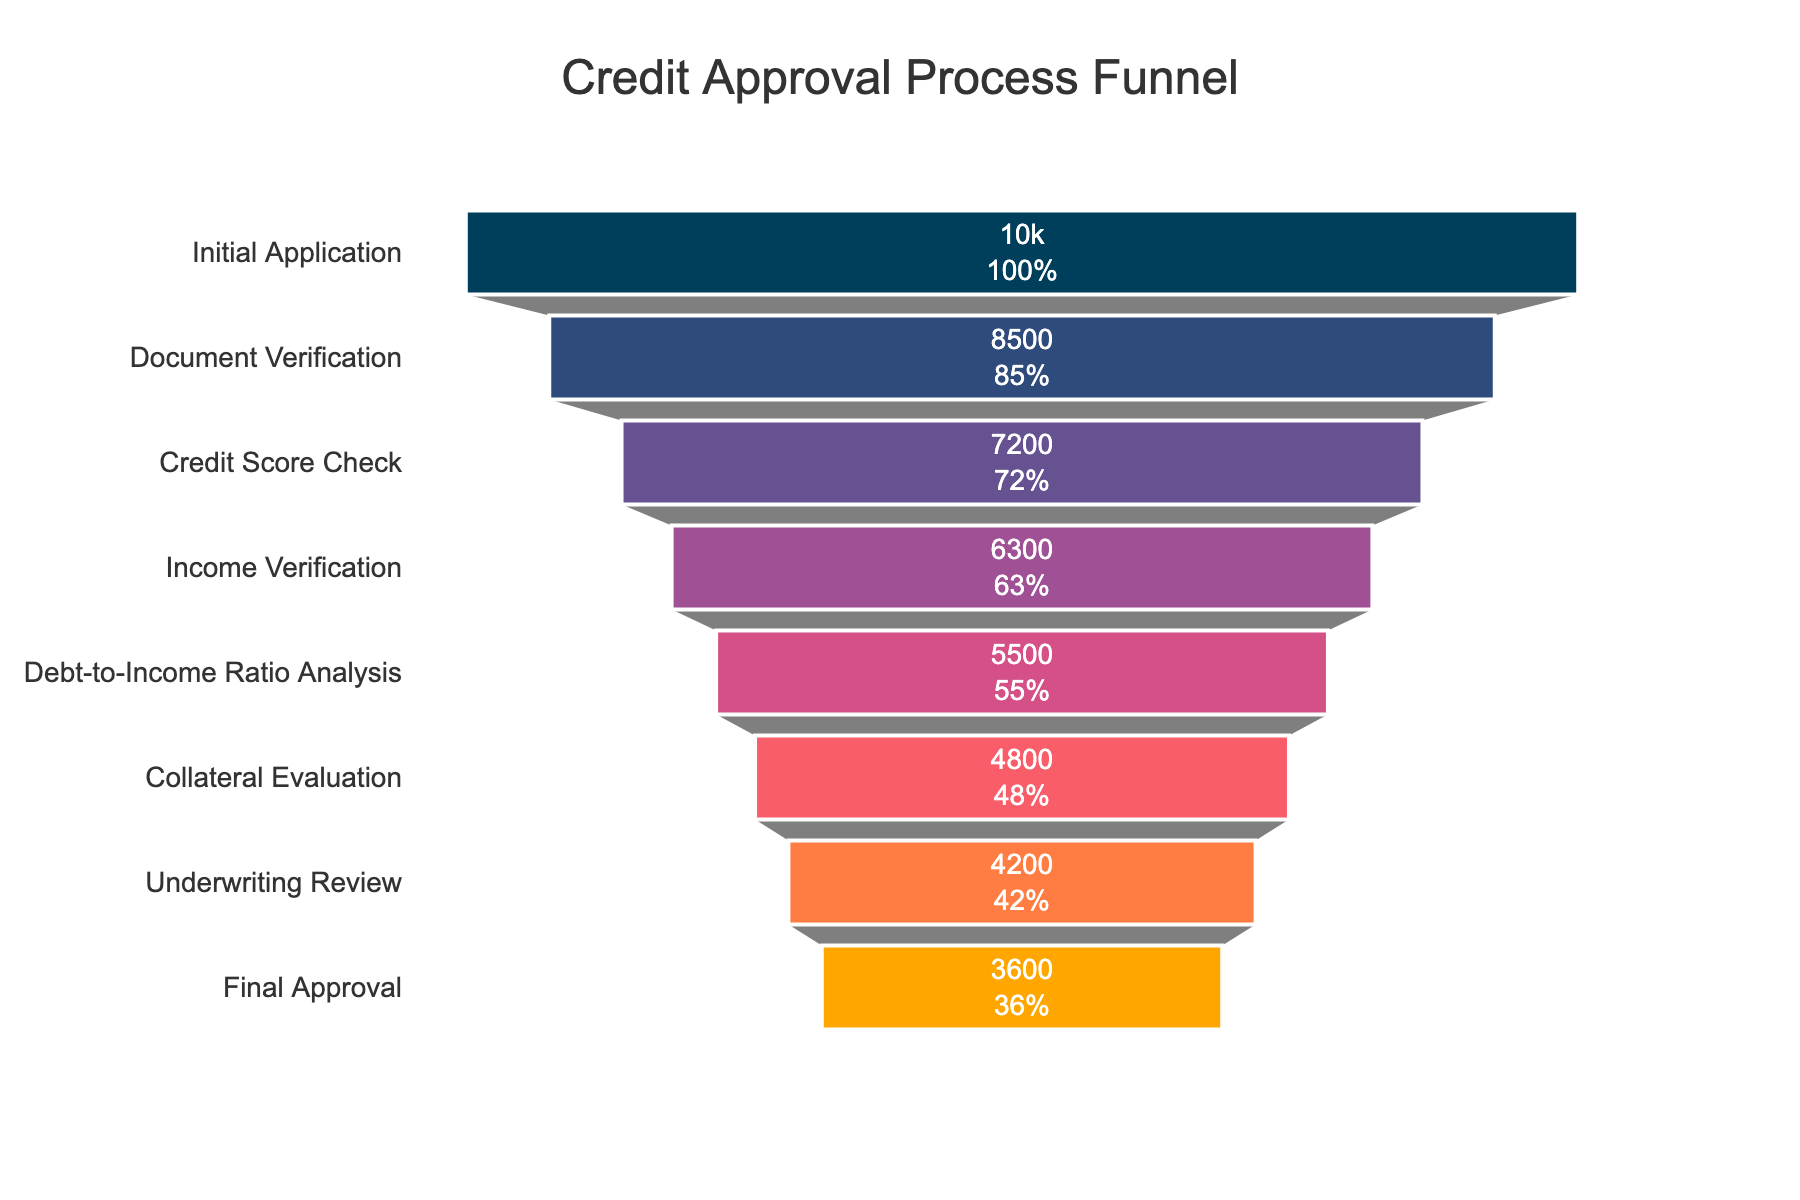What stage has the highest number of applicants? The top of the funnel chart has the greatest width, indicating the stage with the highest number of applicants. This stage is labeled "Initial Application".
Answer: Initial Application What stage sees the biggest drop in applicant numbers? Compare the drop between each sequential stage, i.e., the difference between applicants in each subsequent stage. The biggest drop is between "Initial Application" (10000 applicants) and "Document Verification" (8500 applicants). The difference is 1500 applicants.
Answer: Initial Application to Document Verification How many applicants remain after the Credit Score Check stage? The funnel section corresponding to "Credit Score Check" shows 7200 applicants.
Answer: 7200 What is the percentage of applicants who reach the Final Approval stage relative to the Initial Application stage? To find the percentage, divide the number of applicants at the Final Approval stage (3600) by the number at the Initial Application stage (10000) and multiply by 100: (3600 / 10000) * 100.
Answer: 36% Which stage has around a 20% drop from the previous stage? Calculate the percentage drop for each stage by comparing the current stage's applicants to the prior stage's applicants. The stage where the drop is close to 20% is "Collateral Evaluation" from "Debt-to-Income Ratio Analysis" (5500 - 4800 = 700; 700 / 5500 * 100 = approximately 12.73%) and "Underwriting Review" from "Collateral Evaluation" (4800 - 4200 = 600; 600 / 4800 * 100 = approximately 12.5%).
Answer: No exact match Which stage has the lowest number of applicants? The bottom of the funnel is the narrowest, indicating the lowest number of applicants. This stage is labeled "Final Approval".
Answer: Final Approval What is the total number of applicants lost from the Initial Application stage to the Final Approval stage? Subtract the number of applicants at the Final Approval stage (3600) from those at the Initial Application stage (10000): 10000 - 3600.
Answer: 6400 How many stages have more than 7000 applicants? Count the number of stages where applicant numbers are greater than 7000. These stages are "Initial Application" (10000), "Document Verification" (8500), and "Credit Score Check" (7200).
Answer: 3 Is the drop between each subsequent stage consistent? By comparing the number of applicants between each step, the drop is inconsistent, with varying numbers lost at each stage. For example, the drop from "Initial Application" to "Document Verification" is 1500 applicants, while from "Income Verification" to "Debt-to-Income Ratio Analysis" is 800 applicants.
Answer: No What stage has the highest percentage retention rate from the previous stage? To find the highest retention rate, compare the percentage of applicants retained by dividing the number at each stage by the previous stage's number: "Credit Score Check" (7200 / 8500 ≈ 84.71%), "Document Verification" (8500 / 10000 = 85%). The highest percentage retention is from the first to the second stage.
Answer: Document Verification 